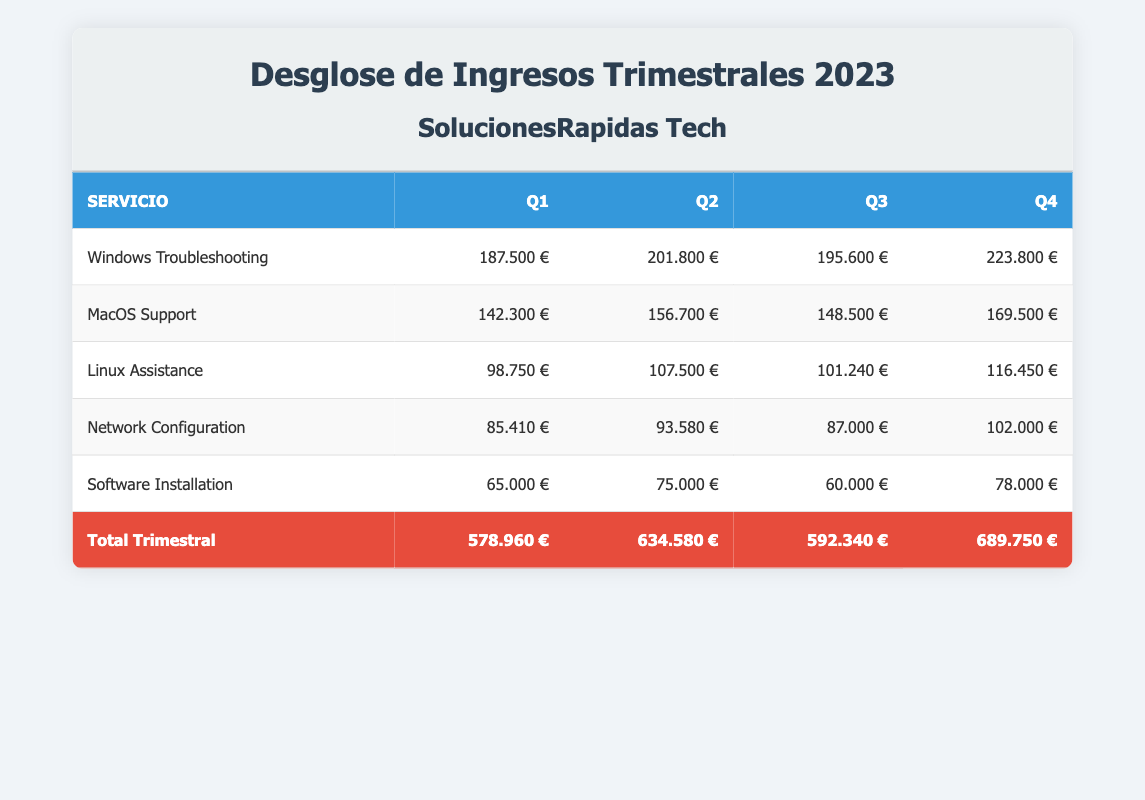¿Cuál fue el total de ingresos en el Q2? El total de ingresos en el Q2 se encuentra en la fila correspondiente a "Total Trimestral" y en la columna de Q2. Se observa que es 634580 €.
Answer: 634580 € ¿Qué servicio generó más ingresos en el Q4? En la fila correspondiente al Q4, se revisan las cifras de ingresos y se compara cada uno. El servicio "Windows Troubleshooting" generó 223800 €, que son los ingresos más altos entre los servicios listados.
Answer: Windows Troubleshooting ¿Cuál es la diferencia en ingresos entre Q1 y Q3? Se toma el total de ingresos del Q1, que es 578960 €, y se resta el total del Q3, que es 592340 €. La diferencia se calcula como 578960 - 592340 = -13380 €, lo que indica que Q3 tuvo más ingresos que Q1.
Answer: -13380 € ¿El ingreso de "Software Installation" aumentó en el Q2 en comparación con el Q1? Se compara el ingreso de "Software Installation" en el Q1 que fue 65000 € con el del Q2 que fue 75000 €. Se observa que el ingreso del Q2 es mayor que el del Q1.
Answer: Sí ¿Cuál fue el ingreso promedio por trimestre para "MacOS Support"? Se suman los ingresos de "MacOS Support" en los cuatro trimestres: 142300 + 156700 + 148500 + 169500 = 616000 €. Luego, se divide este total entre 4 trimestres, lo que resulta en 616000 / 4 = 154000 €.
Answer: 154000 € ¿El ingreso total en el Q4 es más alto que el ingreso total en el Q1 y Q3 combinados? Se suman los ingresos del Q1 (578960 €) y del Q3 (592340 €) para obtener una suma total de 1179300 €. Luego, se compara este total con el ingreso del Q4, que es 689750 €. Dado que 689750 € es menor que 1179300 €, por lo tanto, la afirmación es falsa.
Answer: No ¿Cuánto generó "Linux Assistance" en Q3 en comparación con Q2? Se toma el ingreso de "Linux Assistance" en el Q3 que fue 101240 € y en el Q2 que fue 107500 €. Al comparar, se observa que Q3 tuvo menos ingresos que Q2.
Answer: Menos ¿Qué servicio tuvo el ingreso más bajo en el Q3? En la fila correspondiente al Q3, se revisan los ingresos de los diferentes servicios. Se observa que "Software Installation" generó 60000 €, que es el ingreso más bajo en esa fila.
Answer: Software Installation 